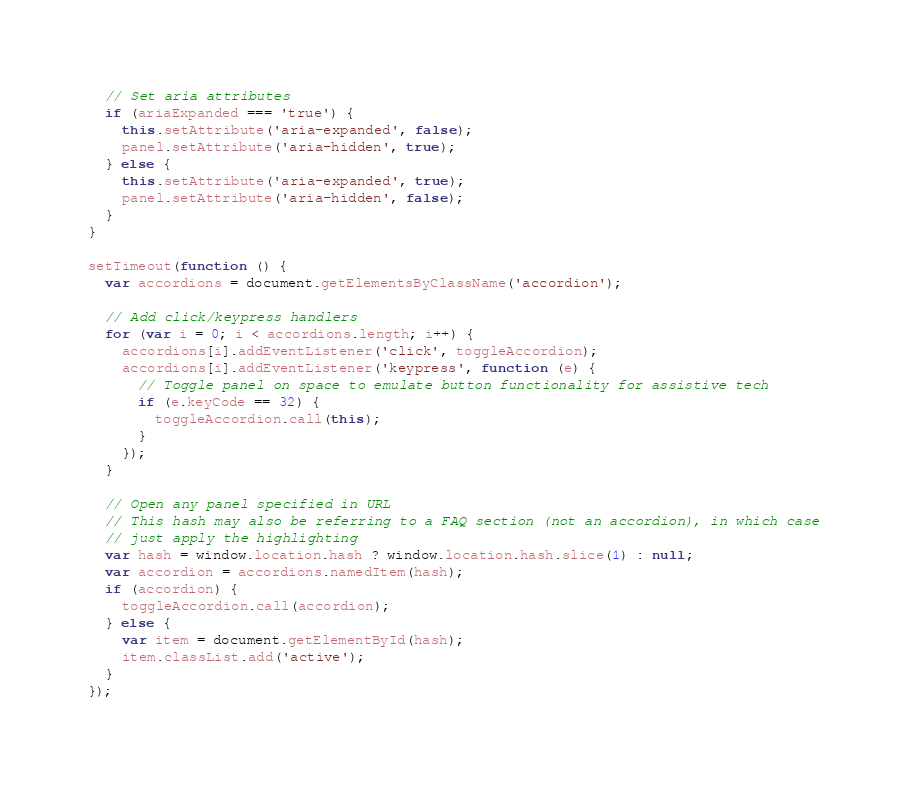<code> <loc_0><loc_0><loc_500><loc_500><_JavaScript_>
  // Set aria attributes
  if (ariaExpanded === 'true') {
    this.setAttribute('aria-expanded', false);
    panel.setAttribute('aria-hidden', true);
  } else {
    this.setAttribute('aria-expanded', true);
    panel.setAttribute('aria-hidden', false);
  }
}

setTimeout(function () {
  var accordions = document.getElementsByClassName('accordion');

  // Add click/keypress handlers
  for (var i = 0; i < accordions.length; i++) {
    accordions[i].addEventListener('click', toggleAccordion);
    accordions[i].addEventListener('keypress', function (e) {
      // Toggle panel on space to emulate button functionality for assistive tech
      if (e.keyCode == 32) {
        toggleAccordion.call(this);
      }
    });
  }

  // Open any panel specified in URL
  // This hash may also be referring to a FAQ section (not an accordion), in which case
  // just apply the highlighting
  var hash = window.location.hash ? window.location.hash.slice(1) : null;
  var accordion = accordions.namedItem(hash);
  if (accordion) {
    toggleAccordion.call(accordion);
  } else {
    var item = document.getElementById(hash);
    item.classList.add('active');
  }
});
</code> 